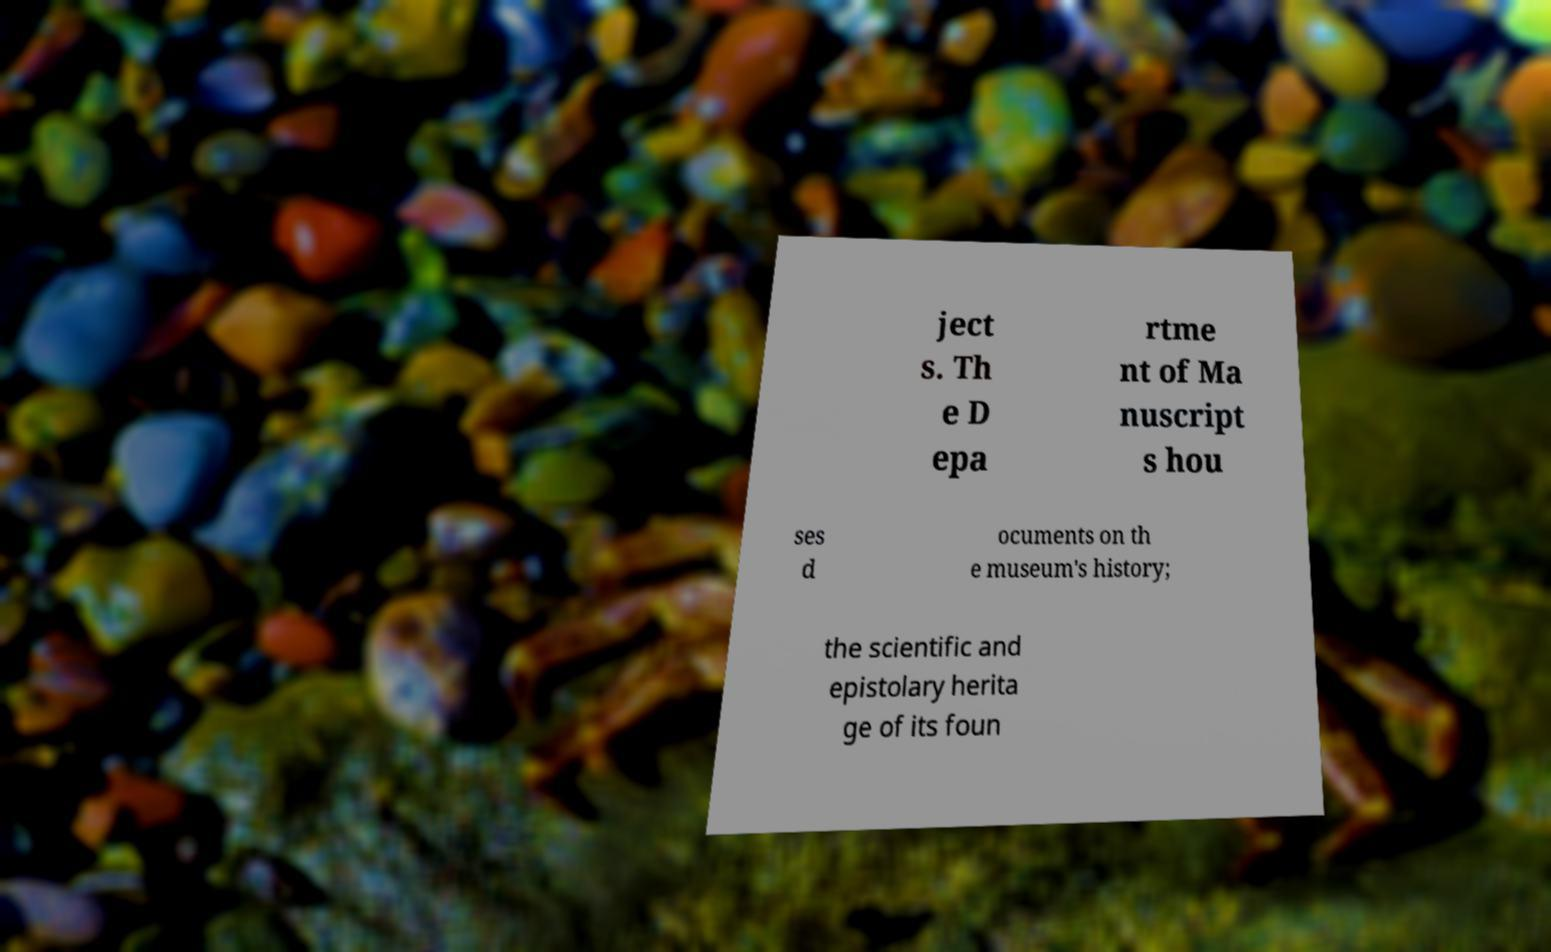What messages or text are displayed in this image? I need them in a readable, typed format. ject s. Th e D epa rtme nt of Ma nuscript s hou ses d ocuments on th e museum's history; the scientific and epistolary herita ge of its foun 